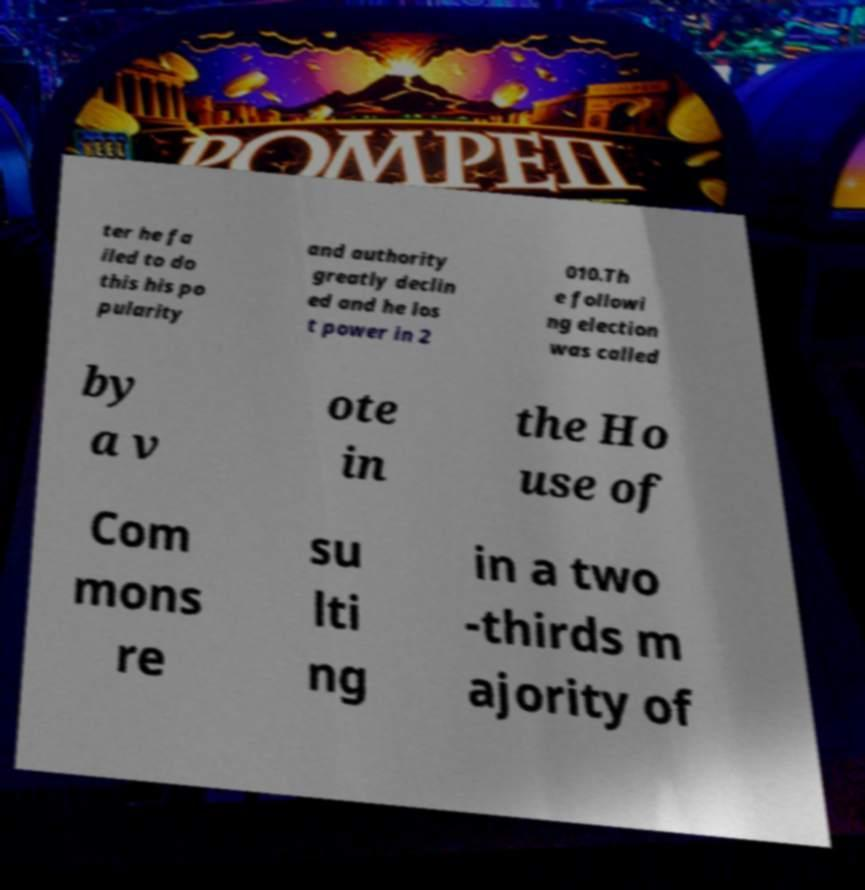Could you assist in decoding the text presented in this image and type it out clearly? ter he fa iled to do this his po pularity and authority greatly declin ed and he los t power in 2 010.Th e followi ng election was called by a v ote in the Ho use of Com mons re su lti ng in a two -thirds m ajority of 